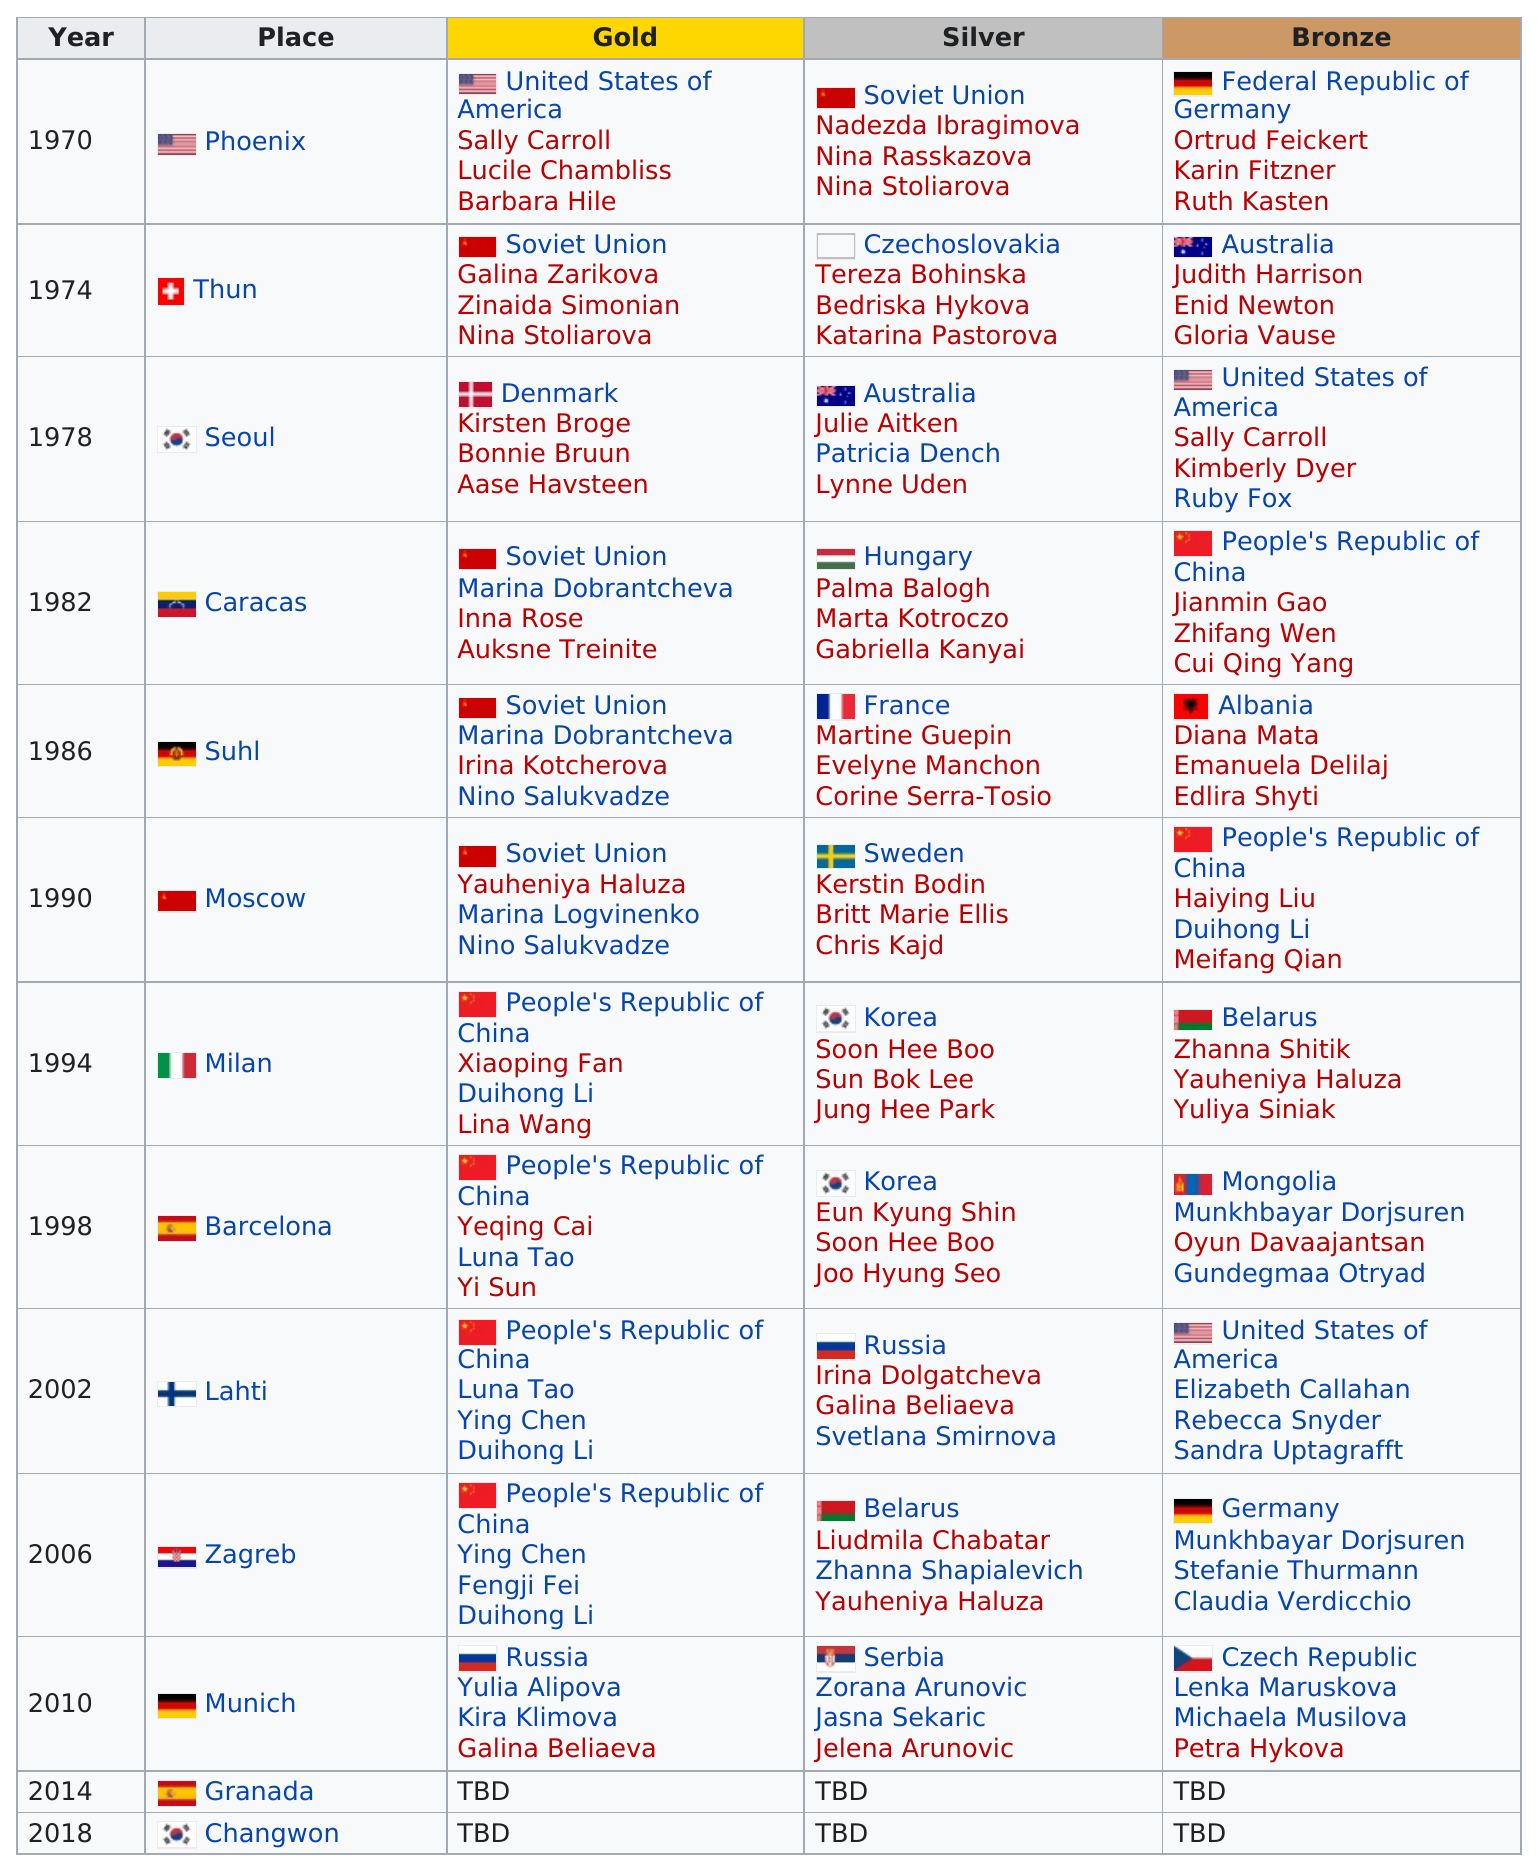Point out several critical features in this image. Germany has won bronze a total of two times. The first place listed in this chart is Phoenix. Korea is the country that is listed the most under the silver column. Sally Carroll was among the top three women who earned gold at the 1970 world championship held in Phoenix, Arizona. The Soviet Union won four first-place titles in the 25m Pistol Women's World Championship. 